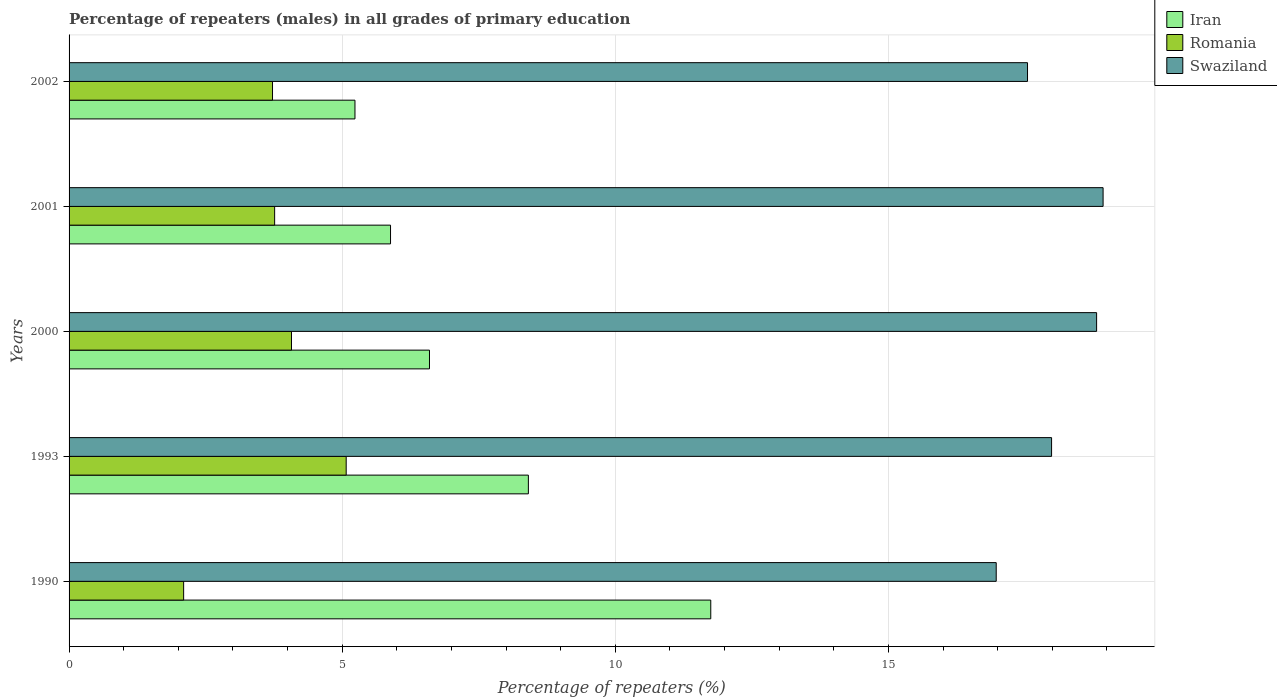How many different coloured bars are there?
Your response must be concise. 3. How many bars are there on the 4th tick from the top?
Offer a terse response. 3. How many bars are there on the 3rd tick from the bottom?
Ensure brevity in your answer.  3. What is the label of the 3rd group of bars from the top?
Offer a very short reply. 2000. In how many cases, is the number of bars for a given year not equal to the number of legend labels?
Your answer should be very brief. 0. What is the percentage of repeaters (males) in Romania in 1993?
Give a very brief answer. 5.07. Across all years, what is the maximum percentage of repeaters (males) in Swaziland?
Offer a terse response. 18.93. Across all years, what is the minimum percentage of repeaters (males) in Swaziland?
Your answer should be compact. 16.97. In which year was the percentage of repeaters (males) in Swaziland maximum?
Your answer should be very brief. 2001. In which year was the percentage of repeaters (males) in Romania minimum?
Provide a short and direct response. 1990. What is the total percentage of repeaters (males) in Romania in the graph?
Your response must be concise. 18.73. What is the difference between the percentage of repeaters (males) in Swaziland in 2000 and that in 2001?
Your response must be concise. -0.12. What is the difference between the percentage of repeaters (males) in Romania in 1990 and the percentage of repeaters (males) in Swaziland in 2002?
Ensure brevity in your answer.  -15.45. What is the average percentage of repeaters (males) in Swaziland per year?
Provide a succinct answer. 18.05. In the year 1993, what is the difference between the percentage of repeaters (males) in Romania and percentage of repeaters (males) in Iran?
Your answer should be very brief. -3.34. What is the ratio of the percentage of repeaters (males) in Romania in 1993 to that in 2002?
Your response must be concise. 1.36. What is the difference between the highest and the second highest percentage of repeaters (males) in Iran?
Your answer should be very brief. 3.34. What is the difference between the highest and the lowest percentage of repeaters (males) in Swaziland?
Offer a terse response. 1.96. Is the sum of the percentage of repeaters (males) in Romania in 2000 and 2001 greater than the maximum percentage of repeaters (males) in Iran across all years?
Your answer should be very brief. No. What does the 1st bar from the top in 1990 represents?
Give a very brief answer. Swaziland. What does the 1st bar from the bottom in 2001 represents?
Offer a very short reply. Iran. Is it the case that in every year, the sum of the percentage of repeaters (males) in Swaziland and percentage of repeaters (males) in Iran is greater than the percentage of repeaters (males) in Romania?
Your answer should be compact. Yes. How many bars are there?
Keep it short and to the point. 15. Are all the bars in the graph horizontal?
Offer a very short reply. Yes. Does the graph contain grids?
Provide a succinct answer. Yes. What is the title of the graph?
Your answer should be compact. Percentage of repeaters (males) in all grades of primary education. What is the label or title of the X-axis?
Offer a terse response. Percentage of repeaters (%). What is the Percentage of repeaters (%) of Iran in 1990?
Give a very brief answer. 11.75. What is the Percentage of repeaters (%) of Romania in 1990?
Ensure brevity in your answer.  2.1. What is the Percentage of repeaters (%) of Swaziland in 1990?
Ensure brevity in your answer.  16.97. What is the Percentage of repeaters (%) in Iran in 1993?
Keep it short and to the point. 8.41. What is the Percentage of repeaters (%) in Romania in 1993?
Your response must be concise. 5.07. What is the Percentage of repeaters (%) in Swaziland in 1993?
Make the answer very short. 17.99. What is the Percentage of repeaters (%) in Iran in 2000?
Your response must be concise. 6.6. What is the Percentage of repeaters (%) of Romania in 2000?
Your answer should be compact. 4.07. What is the Percentage of repeaters (%) of Swaziland in 2000?
Offer a terse response. 18.81. What is the Percentage of repeaters (%) of Iran in 2001?
Offer a terse response. 5.88. What is the Percentage of repeaters (%) in Romania in 2001?
Provide a short and direct response. 3.76. What is the Percentage of repeaters (%) in Swaziland in 2001?
Keep it short and to the point. 18.93. What is the Percentage of repeaters (%) of Iran in 2002?
Ensure brevity in your answer.  5.23. What is the Percentage of repeaters (%) of Romania in 2002?
Provide a short and direct response. 3.72. What is the Percentage of repeaters (%) of Swaziland in 2002?
Give a very brief answer. 17.55. Across all years, what is the maximum Percentage of repeaters (%) in Iran?
Ensure brevity in your answer.  11.75. Across all years, what is the maximum Percentage of repeaters (%) in Romania?
Your answer should be very brief. 5.07. Across all years, what is the maximum Percentage of repeaters (%) of Swaziland?
Provide a succinct answer. 18.93. Across all years, what is the minimum Percentage of repeaters (%) of Iran?
Provide a succinct answer. 5.23. Across all years, what is the minimum Percentage of repeaters (%) in Romania?
Your response must be concise. 2.1. Across all years, what is the minimum Percentage of repeaters (%) in Swaziland?
Give a very brief answer. 16.97. What is the total Percentage of repeaters (%) of Iran in the graph?
Your response must be concise. 37.87. What is the total Percentage of repeaters (%) of Romania in the graph?
Your answer should be compact. 18.73. What is the total Percentage of repeaters (%) in Swaziland in the graph?
Keep it short and to the point. 90.25. What is the difference between the Percentage of repeaters (%) in Iran in 1990 and that in 1993?
Your answer should be very brief. 3.34. What is the difference between the Percentage of repeaters (%) in Romania in 1990 and that in 1993?
Provide a short and direct response. -2.98. What is the difference between the Percentage of repeaters (%) of Swaziland in 1990 and that in 1993?
Provide a short and direct response. -1.01. What is the difference between the Percentage of repeaters (%) in Iran in 1990 and that in 2000?
Make the answer very short. 5.15. What is the difference between the Percentage of repeaters (%) in Romania in 1990 and that in 2000?
Provide a succinct answer. -1.97. What is the difference between the Percentage of repeaters (%) of Swaziland in 1990 and that in 2000?
Keep it short and to the point. -1.84. What is the difference between the Percentage of repeaters (%) of Iran in 1990 and that in 2001?
Ensure brevity in your answer.  5.86. What is the difference between the Percentage of repeaters (%) in Romania in 1990 and that in 2001?
Offer a terse response. -1.67. What is the difference between the Percentage of repeaters (%) in Swaziland in 1990 and that in 2001?
Your answer should be compact. -1.96. What is the difference between the Percentage of repeaters (%) in Iran in 1990 and that in 2002?
Give a very brief answer. 6.51. What is the difference between the Percentage of repeaters (%) in Romania in 1990 and that in 2002?
Your answer should be very brief. -1.63. What is the difference between the Percentage of repeaters (%) of Swaziland in 1990 and that in 2002?
Offer a very short reply. -0.57. What is the difference between the Percentage of repeaters (%) in Iran in 1993 and that in 2000?
Ensure brevity in your answer.  1.81. What is the difference between the Percentage of repeaters (%) in Romania in 1993 and that in 2000?
Make the answer very short. 1. What is the difference between the Percentage of repeaters (%) of Swaziland in 1993 and that in 2000?
Your answer should be compact. -0.82. What is the difference between the Percentage of repeaters (%) of Iran in 1993 and that in 2001?
Keep it short and to the point. 2.52. What is the difference between the Percentage of repeaters (%) of Romania in 1993 and that in 2001?
Your response must be concise. 1.31. What is the difference between the Percentage of repeaters (%) of Swaziland in 1993 and that in 2001?
Give a very brief answer. -0.94. What is the difference between the Percentage of repeaters (%) of Iran in 1993 and that in 2002?
Ensure brevity in your answer.  3.17. What is the difference between the Percentage of repeaters (%) in Romania in 1993 and that in 2002?
Your answer should be compact. 1.35. What is the difference between the Percentage of repeaters (%) in Swaziland in 1993 and that in 2002?
Your answer should be compact. 0.44. What is the difference between the Percentage of repeaters (%) of Iran in 2000 and that in 2001?
Your answer should be very brief. 0.71. What is the difference between the Percentage of repeaters (%) in Romania in 2000 and that in 2001?
Offer a terse response. 0.31. What is the difference between the Percentage of repeaters (%) in Swaziland in 2000 and that in 2001?
Give a very brief answer. -0.12. What is the difference between the Percentage of repeaters (%) of Iran in 2000 and that in 2002?
Keep it short and to the point. 1.36. What is the difference between the Percentage of repeaters (%) of Romania in 2000 and that in 2002?
Your answer should be compact. 0.35. What is the difference between the Percentage of repeaters (%) of Swaziland in 2000 and that in 2002?
Keep it short and to the point. 1.26. What is the difference between the Percentage of repeaters (%) in Iran in 2001 and that in 2002?
Your answer should be compact. 0.65. What is the difference between the Percentage of repeaters (%) in Romania in 2001 and that in 2002?
Your answer should be compact. 0.04. What is the difference between the Percentage of repeaters (%) in Swaziland in 2001 and that in 2002?
Offer a terse response. 1.38. What is the difference between the Percentage of repeaters (%) of Iran in 1990 and the Percentage of repeaters (%) of Romania in 1993?
Your answer should be very brief. 6.67. What is the difference between the Percentage of repeaters (%) in Iran in 1990 and the Percentage of repeaters (%) in Swaziland in 1993?
Keep it short and to the point. -6.24. What is the difference between the Percentage of repeaters (%) in Romania in 1990 and the Percentage of repeaters (%) in Swaziland in 1993?
Give a very brief answer. -15.89. What is the difference between the Percentage of repeaters (%) of Iran in 1990 and the Percentage of repeaters (%) of Romania in 2000?
Your answer should be compact. 7.68. What is the difference between the Percentage of repeaters (%) in Iran in 1990 and the Percentage of repeaters (%) in Swaziland in 2000?
Give a very brief answer. -7.06. What is the difference between the Percentage of repeaters (%) in Romania in 1990 and the Percentage of repeaters (%) in Swaziland in 2000?
Give a very brief answer. -16.71. What is the difference between the Percentage of repeaters (%) in Iran in 1990 and the Percentage of repeaters (%) in Romania in 2001?
Your response must be concise. 7.98. What is the difference between the Percentage of repeaters (%) of Iran in 1990 and the Percentage of repeaters (%) of Swaziland in 2001?
Make the answer very short. -7.18. What is the difference between the Percentage of repeaters (%) of Romania in 1990 and the Percentage of repeaters (%) of Swaziland in 2001?
Give a very brief answer. -16.83. What is the difference between the Percentage of repeaters (%) of Iran in 1990 and the Percentage of repeaters (%) of Romania in 2002?
Your response must be concise. 8.02. What is the difference between the Percentage of repeaters (%) of Iran in 1990 and the Percentage of repeaters (%) of Swaziland in 2002?
Provide a short and direct response. -5.8. What is the difference between the Percentage of repeaters (%) of Romania in 1990 and the Percentage of repeaters (%) of Swaziland in 2002?
Provide a succinct answer. -15.45. What is the difference between the Percentage of repeaters (%) of Iran in 1993 and the Percentage of repeaters (%) of Romania in 2000?
Your answer should be very brief. 4.34. What is the difference between the Percentage of repeaters (%) of Iran in 1993 and the Percentage of repeaters (%) of Swaziland in 2000?
Make the answer very short. -10.4. What is the difference between the Percentage of repeaters (%) in Romania in 1993 and the Percentage of repeaters (%) in Swaziland in 2000?
Provide a succinct answer. -13.74. What is the difference between the Percentage of repeaters (%) in Iran in 1993 and the Percentage of repeaters (%) in Romania in 2001?
Your answer should be compact. 4.65. What is the difference between the Percentage of repeaters (%) of Iran in 1993 and the Percentage of repeaters (%) of Swaziland in 2001?
Your answer should be very brief. -10.52. What is the difference between the Percentage of repeaters (%) in Romania in 1993 and the Percentage of repeaters (%) in Swaziland in 2001?
Give a very brief answer. -13.86. What is the difference between the Percentage of repeaters (%) of Iran in 1993 and the Percentage of repeaters (%) of Romania in 2002?
Give a very brief answer. 4.68. What is the difference between the Percentage of repeaters (%) in Iran in 1993 and the Percentage of repeaters (%) in Swaziland in 2002?
Offer a terse response. -9.14. What is the difference between the Percentage of repeaters (%) in Romania in 1993 and the Percentage of repeaters (%) in Swaziland in 2002?
Your answer should be very brief. -12.47. What is the difference between the Percentage of repeaters (%) in Iran in 2000 and the Percentage of repeaters (%) in Romania in 2001?
Offer a very short reply. 2.83. What is the difference between the Percentage of repeaters (%) of Iran in 2000 and the Percentage of repeaters (%) of Swaziland in 2001?
Make the answer very short. -12.33. What is the difference between the Percentage of repeaters (%) of Romania in 2000 and the Percentage of repeaters (%) of Swaziland in 2001?
Your answer should be very brief. -14.86. What is the difference between the Percentage of repeaters (%) in Iran in 2000 and the Percentage of repeaters (%) in Romania in 2002?
Provide a short and direct response. 2.87. What is the difference between the Percentage of repeaters (%) in Iran in 2000 and the Percentage of repeaters (%) in Swaziland in 2002?
Ensure brevity in your answer.  -10.95. What is the difference between the Percentage of repeaters (%) of Romania in 2000 and the Percentage of repeaters (%) of Swaziland in 2002?
Offer a very short reply. -13.47. What is the difference between the Percentage of repeaters (%) of Iran in 2001 and the Percentage of repeaters (%) of Romania in 2002?
Offer a terse response. 2.16. What is the difference between the Percentage of repeaters (%) in Iran in 2001 and the Percentage of repeaters (%) in Swaziland in 2002?
Provide a succinct answer. -11.66. What is the difference between the Percentage of repeaters (%) of Romania in 2001 and the Percentage of repeaters (%) of Swaziland in 2002?
Your answer should be compact. -13.78. What is the average Percentage of repeaters (%) of Iran per year?
Ensure brevity in your answer.  7.57. What is the average Percentage of repeaters (%) of Romania per year?
Ensure brevity in your answer.  3.75. What is the average Percentage of repeaters (%) of Swaziland per year?
Offer a very short reply. 18.05. In the year 1990, what is the difference between the Percentage of repeaters (%) of Iran and Percentage of repeaters (%) of Romania?
Keep it short and to the point. 9.65. In the year 1990, what is the difference between the Percentage of repeaters (%) in Iran and Percentage of repeaters (%) in Swaziland?
Ensure brevity in your answer.  -5.23. In the year 1990, what is the difference between the Percentage of repeaters (%) in Romania and Percentage of repeaters (%) in Swaziland?
Offer a terse response. -14.88. In the year 1993, what is the difference between the Percentage of repeaters (%) of Iran and Percentage of repeaters (%) of Romania?
Make the answer very short. 3.34. In the year 1993, what is the difference between the Percentage of repeaters (%) in Iran and Percentage of repeaters (%) in Swaziland?
Your answer should be compact. -9.58. In the year 1993, what is the difference between the Percentage of repeaters (%) of Romania and Percentage of repeaters (%) of Swaziland?
Provide a short and direct response. -12.91. In the year 2000, what is the difference between the Percentage of repeaters (%) of Iran and Percentage of repeaters (%) of Romania?
Your answer should be compact. 2.53. In the year 2000, what is the difference between the Percentage of repeaters (%) in Iran and Percentage of repeaters (%) in Swaziland?
Ensure brevity in your answer.  -12.21. In the year 2000, what is the difference between the Percentage of repeaters (%) in Romania and Percentage of repeaters (%) in Swaziland?
Provide a short and direct response. -14.74. In the year 2001, what is the difference between the Percentage of repeaters (%) in Iran and Percentage of repeaters (%) in Romania?
Provide a short and direct response. 2.12. In the year 2001, what is the difference between the Percentage of repeaters (%) of Iran and Percentage of repeaters (%) of Swaziland?
Your response must be concise. -13.04. In the year 2001, what is the difference between the Percentage of repeaters (%) in Romania and Percentage of repeaters (%) in Swaziland?
Your answer should be very brief. -15.17. In the year 2002, what is the difference between the Percentage of repeaters (%) of Iran and Percentage of repeaters (%) of Romania?
Your answer should be very brief. 1.51. In the year 2002, what is the difference between the Percentage of repeaters (%) in Iran and Percentage of repeaters (%) in Swaziland?
Provide a succinct answer. -12.31. In the year 2002, what is the difference between the Percentage of repeaters (%) of Romania and Percentage of repeaters (%) of Swaziland?
Your answer should be compact. -13.82. What is the ratio of the Percentage of repeaters (%) of Iran in 1990 to that in 1993?
Ensure brevity in your answer.  1.4. What is the ratio of the Percentage of repeaters (%) in Romania in 1990 to that in 1993?
Your answer should be compact. 0.41. What is the ratio of the Percentage of repeaters (%) of Swaziland in 1990 to that in 1993?
Give a very brief answer. 0.94. What is the ratio of the Percentage of repeaters (%) of Iran in 1990 to that in 2000?
Your response must be concise. 1.78. What is the ratio of the Percentage of repeaters (%) in Romania in 1990 to that in 2000?
Keep it short and to the point. 0.52. What is the ratio of the Percentage of repeaters (%) of Swaziland in 1990 to that in 2000?
Offer a terse response. 0.9. What is the ratio of the Percentage of repeaters (%) in Iran in 1990 to that in 2001?
Make the answer very short. 2. What is the ratio of the Percentage of repeaters (%) of Romania in 1990 to that in 2001?
Give a very brief answer. 0.56. What is the ratio of the Percentage of repeaters (%) in Swaziland in 1990 to that in 2001?
Give a very brief answer. 0.9. What is the ratio of the Percentage of repeaters (%) in Iran in 1990 to that in 2002?
Provide a succinct answer. 2.24. What is the ratio of the Percentage of repeaters (%) in Romania in 1990 to that in 2002?
Your answer should be compact. 0.56. What is the ratio of the Percentage of repeaters (%) of Swaziland in 1990 to that in 2002?
Make the answer very short. 0.97. What is the ratio of the Percentage of repeaters (%) of Iran in 1993 to that in 2000?
Keep it short and to the point. 1.27. What is the ratio of the Percentage of repeaters (%) in Romania in 1993 to that in 2000?
Your answer should be very brief. 1.25. What is the ratio of the Percentage of repeaters (%) of Swaziland in 1993 to that in 2000?
Your answer should be very brief. 0.96. What is the ratio of the Percentage of repeaters (%) of Iran in 1993 to that in 2001?
Keep it short and to the point. 1.43. What is the ratio of the Percentage of repeaters (%) in Romania in 1993 to that in 2001?
Your answer should be compact. 1.35. What is the ratio of the Percentage of repeaters (%) in Swaziland in 1993 to that in 2001?
Ensure brevity in your answer.  0.95. What is the ratio of the Percentage of repeaters (%) of Iran in 1993 to that in 2002?
Your response must be concise. 1.61. What is the ratio of the Percentage of repeaters (%) of Romania in 1993 to that in 2002?
Your response must be concise. 1.36. What is the ratio of the Percentage of repeaters (%) in Swaziland in 1993 to that in 2002?
Your response must be concise. 1.03. What is the ratio of the Percentage of repeaters (%) in Iran in 2000 to that in 2001?
Make the answer very short. 1.12. What is the ratio of the Percentage of repeaters (%) of Romania in 2000 to that in 2001?
Give a very brief answer. 1.08. What is the ratio of the Percentage of repeaters (%) of Swaziland in 2000 to that in 2001?
Your response must be concise. 0.99. What is the ratio of the Percentage of repeaters (%) of Iran in 2000 to that in 2002?
Your answer should be compact. 1.26. What is the ratio of the Percentage of repeaters (%) of Romania in 2000 to that in 2002?
Ensure brevity in your answer.  1.09. What is the ratio of the Percentage of repeaters (%) of Swaziland in 2000 to that in 2002?
Give a very brief answer. 1.07. What is the ratio of the Percentage of repeaters (%) in Iran in 2001 to that in 2002?
Your answer should be very brief. 1.12. What is the ratio of the Percentage of repeaters (%) of Romania in 2001 to that in 2002?
Your answer should be compact. 1.01. What is the ratio of the Percentage of repeaters (%) of Swaziland in 2001 to that in 2002?
Provide a short and direct response. 1.08. What is the difference between the highest and the second highest Percentage of repeaters (%) in Iran?
Your answer should be very brief. 3.34. What is the difference between the highest and the second highest Percentage of repeaters (%) of Swaziland?
Your answer should be compact. 0.12. What is the difference between the highest and the lowest Percentage of repeaters (%) in Iran?
Make the answer very short. 6.51. What is the difference between the highest and the lowest Percentage of repeaters (%) of Romania?
Ensure brevity in your answer.  2.98. What is the difference between the highest and the lowest Percentage of repeaters (%) in Swaziland?
Your answer should be very brief. 1.96. 